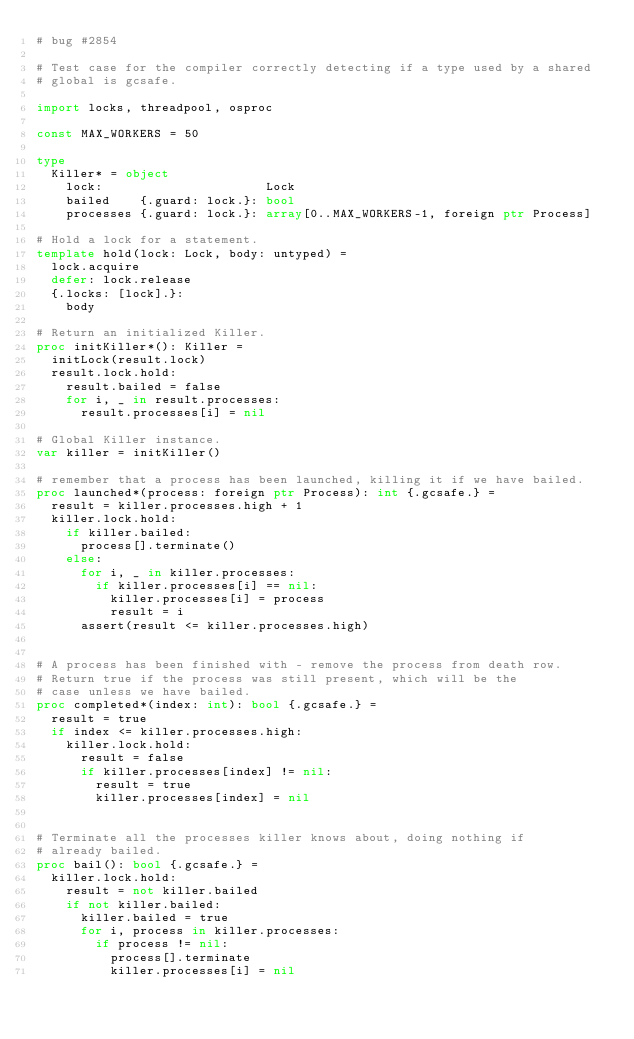<code> <loc_0><loc_0><loc_500><loc_500><_Nim_># bug #2854

# Test case for the compiler correctly detecting if a type used by a shared
# global is gcsafe.

import locks, threadpool, osproc

const MAX_WORKERS = 50

type
  Killer* = object
    lock:                      Lock
    bailed    {.guard: lock.}: bool
    processes {.guard: lock.}: array[0..MAX_WORKERS-1, foreign ptr Process]

# Hold a lock for a statement.
template hold(lock: Lock, body: untyped) =
  lock.acquire
  defer: lock.release
  {.locks: [lock].}:
    body

# Return an initialized Killer.
proc initKiller*(): Killer =
  initLock(result.lock)
  result.lock.hold:
    result.bailed = false
    for i, _ in result.processes:
      result.processes[i] = nil

# Global Killer instance.
var killer = initKiller()

# remember that a process has been launched, killing it if we have bailed.
proc launched*(process: foreign ptr Process): int {.gcsafe.} =
  result = killer.processes.high + 1
  killer.lock.hold:
    if killer.bailed:
      process[].terminate()
    else:
      for i, _ in killer.processes:
        if killer.processes[i] == nil:
          killer.processes[i] = process
          result = i
      assert(result <= killer.processes.high)


# A process has been finished with - remove the process from death row.
# Return true if the process was still present, which will be the
# case unless we have bailed.
proc completed*(index: int): bool {.gcsafe.} =
  result = true
  if index <= killer.processes.high:
    killer.lock.hold:
      result = false
      if killer.processes[index] != nil:
        result = true
        killer.processes[index] = nil


# Terminate all the processes killer knows about, doing nothing if
# already bailed.
proc bail(): bool {.gcsafe.} =
  killer.lock.hold:
    result = not killer.bailed
    if not killer.bailed:
      killer.bailed = true
      for i, process in killer.processes:
        if process != nil:
          process[].terminate
          killer.processes[i] = nil
</code> 